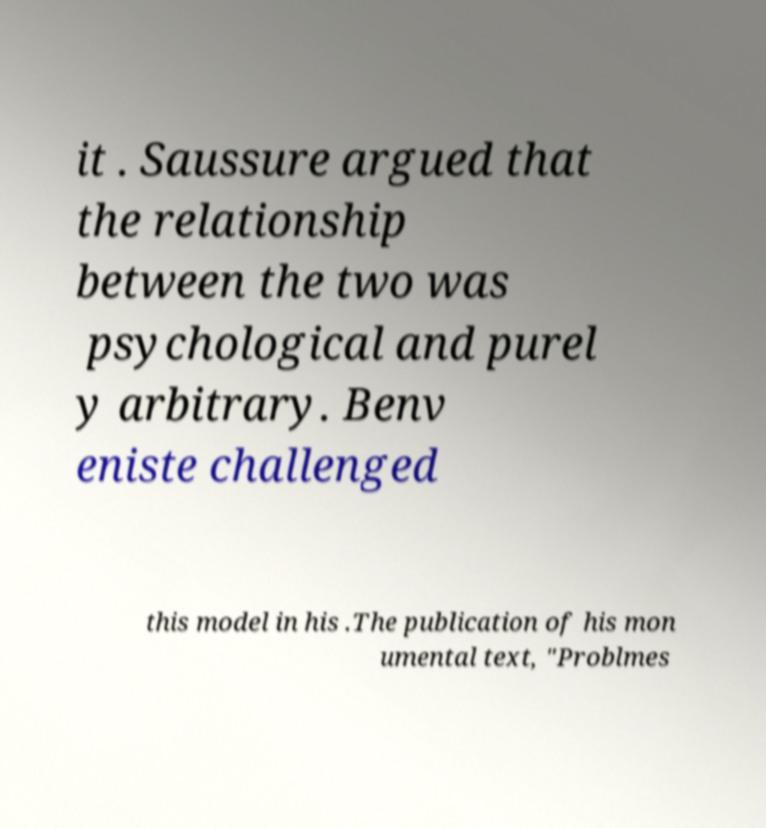Please identify and transcribe the text found in this image. it . Saussure argued that the relationship between the two was psychological and purel y arbitrary. Benv eniste challenged this model in his .The publication of his mon umental text, "Problmes 